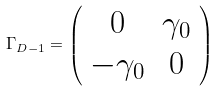<formula> <loc_0><loc_0><loc_500><loc_500>\Gamma _ { D - 1 } = \left ( \begin{array} { c c } 0 & \gamma _ { 0 } \\ - \gamma _ { 0 } & 0 \end{array} \right )</formula> 